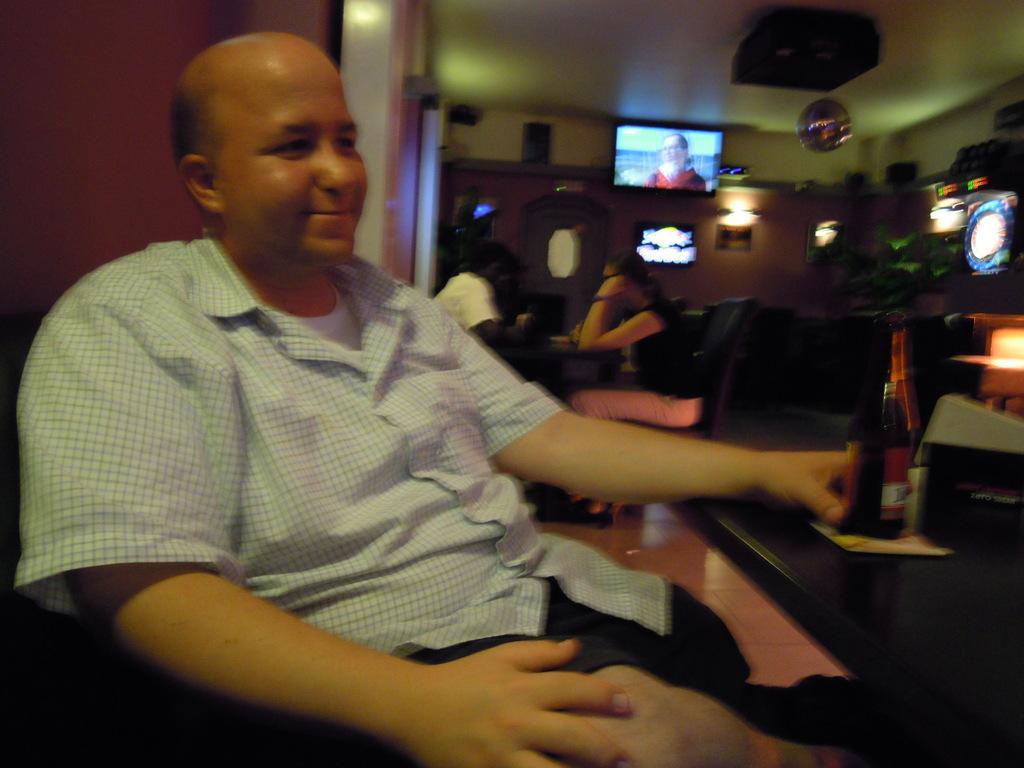In one or two sentences, can you explain what this image depicts? In this image we can see people sitting. There are chairs and tables. We can see a bottle and an object placed on the table. In the background there is a screen and we can see decors. There are lights and we can see a wall. 